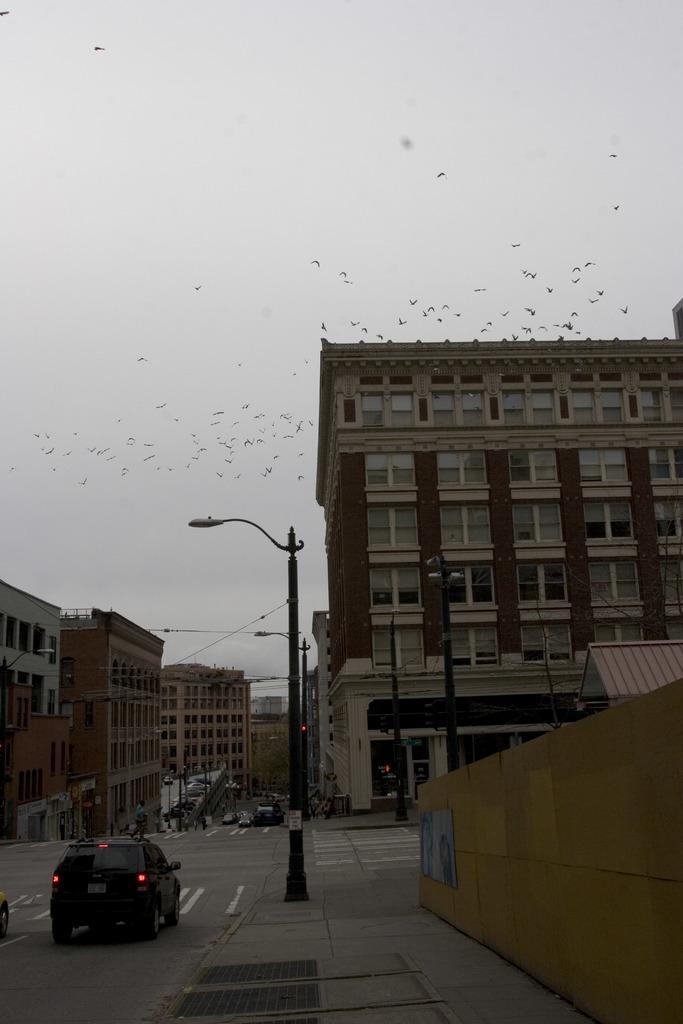In one or two sentences, can you explain what this image depicts? In the image we can see a building and these are the window of the building, and there is a vehicle on the road. This is a light pole, electrical wire, the sky and there are birds flying. 